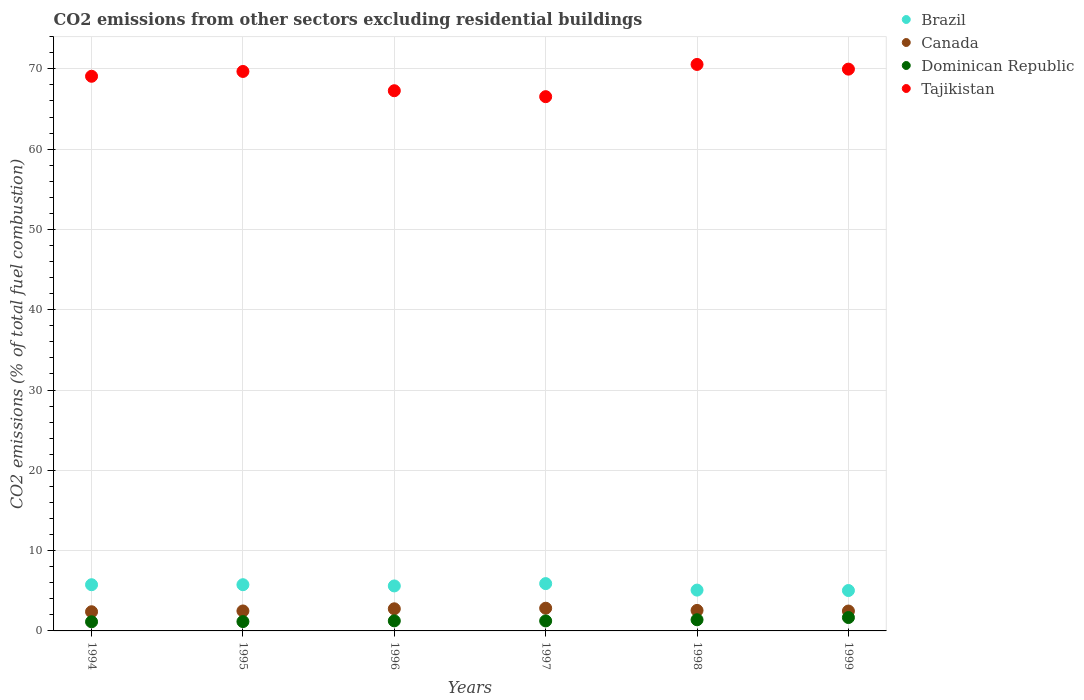How many different coloured dotlines are there?
Provide a succinct answer. 4. What is the total CO2 emitted in Tajikistan in 1994?
Provide a short and direct response. 69.07. Across all years, what is the maximum total CO2 emitted in Dominican Republic?
Provide a succinct answer. 1.67. Across all years, what is the minimum total CO2 emitted in Tajikistan?
Your answer should be very brief. 66.53. In which year was the total CO2 emitted in Dominican Republic maximum?
Keep it short and to the point. 1999. In which year was the total CO2 emitted in Tajikistan minimum?
Your response must be concise. 1997. What is the total total CO2 emitted in Canada in the graph?
Your answer should be compact. 15.49. What is the difference between the total CO2 emitted in Tajikistan in 1997 and that in 1999?
Ensure brevity in your answer.  -3.43. What is the difference between the total CO2 emitted in Brazil in 1997 and the total CO2 emitted in Tajikistan in 1996?
Ensure brevity in your answer.  -61.38. What is the average total CO2 emitted in Canada per year?
Ensure brevity in your answer.  2.58. In the year 1999, what is the difference between the total CO2 emitted in Dominican Republic and total CO2 emitted in Canada?
Give a very brief answer. -0.81. In how many years, is the total CO2 emitted in Canada greater than 58?
Ensure brevity in your answer.  0. What is the ratio of the total CO2 emitted in Canada in 1997 to that in 1998?
Your answer should be compact. 1.11. Is the difference between the total CO2 emitted in Dominican Republic in 1994 and 1999 greater than the difference between the total CO2 emitted in Canada in 1994 and 1999?
Give a very brief answer. No. What is the difference between the highest and the second highest total CO2 emitted in Canada?
Your response must be concise. 0.07. What is the difference between the highest and the lowest total CO2 emitted in Brazil?
Your answer should be very brief. 0.86. Is it the case that in every year, the sum of the total CO2 emitted in Tajikistan and total CO2 emitted in Canada  is greater than the sum of total CO2 emitted in Dominican Republic and total CO2 emitted in Brazil?
Make the answer very short. Yes. Is it the case that in every year, the sum of the total CO2 emitted in Dominican Republic and total CO2 emitted in Canada  is greater than the total CO2 emitted in Tajikistan?
Your response must be concise. No. Does the total CO2 emitted in Dominican Republic monotonically increase over the years?
Ensure brevity in your answer.  No. Is the total CO2 emitted in Brazil strictly greater than the total CO2 emitted in Tajikistan over the years?
Make the answer very short. No. Is the total CO2 emitted in Brazil strictly less than the total CO2 emitted in Tajikistan over the years?
Offer a very short reply. Yes. How many dotlines are there?
Provide a succinct answer. 4. How many years are there in the graph?
Provide a succinct answer. 6. What is the difference between two consecutive major ticks on the Y-axis?
Keep it short and to the point. 10. Are the values on the major ticks of Y-axis written in scientific E-notation?
Ensure brevity in your answer.  No. Does the graph contain any zero values?
Offer a very short reply. No. Does the graph contain grids?
Offer a very short reply. Yes. How are the legend labels stacked?
Provide a short and direct response. Vertical. What is the title of the graph?
Offer a terse response. CO2 emissions from other sectors excluding residential buildings. What is the label or title of the X-axis?
Your answer should be very brief. Years. What is the label or title of the Y-axis?
Provide a short and direct response. CO2 emissions (% of total fuel combustion). What is the CO2 emissions (% of total fuel combustion) of Brazil in 1994?
Keep it short and to the point. 5.75. What is the CO2 emissions (% of total fuel combustion) of Canada in 1994?
Provide a short and direct response. 2.39. What is the CO2 emissions (% of total fuel combustion) of Dominican Republic in 1994?
Make the answer very short. 1.14. What is the CO2 emissions (% of total fuel combustion) in Tajikistan in 1994?
Offer a terse response. 69.07. What is the CO2 emissions (% of total fuel combustion) in Brazil in 1995?
Provide a short and direct response. 5.76. What is the CO2 emissions (% of total fuel combustion) of Canada in 1995?
Ensure brevity in your answer.  2.49. What is the CO2 emissions (% of total fuel combustion) of Dominican Republic in 1995?
Make the answer very short. 1.16. What is the CO2 emissions (% of total fuel combustion) of Tajikistan in 1995?
Give a very brief answer. 69.67. What is the CO2 emissions (% of total fuel combustion) of Brazil in 1996?
Keep it short and to the point. 5.6. What is the CO2 emissions (% of total fuel combustion) in Canada in 1996?
Ensure brevity in your answer.  2.76. What is the CO2 emissions (% of total fuel combustion) in Dominican Republic in 1996?
Keep it short and to the point. 1.25. What is the CO2 emissions (% of total fuel combustion) of Tajikistan in 1996?
Provide a short and direct response. 67.27. What is the CO2 emissions (% of total fuel combustion) of Brazil in 1997?
Give a very brief answer. 5.89. What is the CO2 emissions (% of total fuel combustion) of Canada in 1997?
Your answer should be very brief. 2.83. What is the CO2 emissions (% of total fuel combustion) in Dominican Republic in 1997?
Offer a very short reply. 1.25. What is the CO2 emissions (% of total fuel combustion) in Tajikistan in 1997?
Your answer should be very brief. 66.53. What is the CO2 emissions (% of total fuel combustion) in Brazil in 1998?
Keep it short and to the point. 5.08. What is the CO2 emissions (% of total fuel combustion) in Canada in 1998?
Give a very brief answer. 2.55. What is the CO2 emissions (% of total fuel combustion) in Dominican Republic in 1998?
Offer a terse response. 1.39. What is the CO2 emissions (% of total fuel combustion) in Tajikistan in 1998?
Your answer should be compact. 70.55. What is the CO2 emissions (% of total fuel combustion) in Brazil in 1999?
Ensure brevity in your answer.  5.03. What is the CO2 emissions (% of total fuel combustion) in Canada in 1999?
Your answer should be very brief. 2.48. What is the CO2 emissions (% of total fuel combustion) in Dominican Republic in 1999?
Keep it short and to the point. 1.67. What is the CO2 emissions (% of total fuel combustion) in Tajikistan in 1999?
Your answer should be compact. 69.96. Across all years, what is the maximum CO2 emissions (% of total fuel combustion) in Brazil?
Your answer should be compact. 5.89. Across all years, what is the maximum CO2 emissions (% of total fuel combustion) in Canada?
Ensure brevity in your answer.  2.83. Across all years, what is the maximum CO2 emissions (% of total fuel combustion) in Dominican Republic?
Your answer should be compact. 1.67. Across all years, what is the maximum CO2 emissions (% of total fuel combustion) in Tajikistan?
Keep it short and to the point. 70.55. Across all years, what is the minimum CO2 emissions (% of total fuel combustion) of Brazil?
Offer a terse response. 5.03. Across all years, what is the minimum CO2 emissions (% of total fuel combustion) in Canada?
Offer a very short reply. 2.39. Across all years, what is the minimum CO2 emissions (% of total fuel combustion) in Dominican Republic?
Your answer should be compact. 1.14. Across all years, what is the minimum CO2 emissions (% of total fuel combustion) of Tajikistan?
Ensure brevity in your answer.  66.53. What is the total CO2 emissions (% of total fuel combustion) in Brazil in the graph?
Your answer should be very brief. 33.12. What is the total CO2 emissions (% of total fuel combustion) of Canada in the graph?
Provide a short and direct response. 15.49. What is the total CO2 emissions (% of total fuel combustion) of Dominican Republic in the graph?
Your response must be concise. 7.86. What is the total CO2 emissions (% of total fuel combustion) in Tajikistan in the graph?
Keep it short and to the point. 413.06. What is the difference between the CO2 emissions (% of total fuel combustion) of Brazil in 1994 and that in 1995?
Provide a succinct answer. -0. What is the difference between the CO2 emissions (% of total fuel combustion) in Canada in 1994 and that in 1995?
Make the answer very short. -0.1. What is the difference between the CO2 emissions (% of total fuel combustion) in Dominican Republic in 1994 and that in 1995?
Give a very brief answer. -0.02. What is the difference between the CO2 emissions (% of total fuel combustion) of Brazil in 1994 and that in 1996?
Your answer should be very brief. 0.15. What is the difference between the CO2 emissions (% of total fuel combustion) in Canada in 1994 and that in 1996?
Your answer should be compact. -0.37. What is the difference between the CO2 emissions (% of total fuel combustion) in Dominican Republic in 1994 and that in 1996?
Provide a short and direct response. -0.11. What is the difference between the CO2 emissions (% of total fuel combustion) of Tajikistan in 1994 and that in 1996?
Your response must be concise. 1.8. What is the difference between the CO2 emissions (% of total fuel combustion) of Brazil in 1994 and that in 1997?
Ensure brevity in your answer.  -0.14. What is the difference between the CO2 emissions (% of total fuel combustion) in Canada in 1994 and that in 1997?
Provide a succinct answer. -0.44. What is the difference between the CO2 emissions (% of total fuel combustion) of Dominican Republic in 1994 and that in 1997?
Make the answer very short. -0.11. What is the difference between the CO2 emissions (% of total fuel combustion) of Tajikistan in 1994 and that in 1997?
Your answer should be very brief. 2.54. What is the difference between the CO2 emissions (% of total fuel combustion) of Brazil in 1994 and that in 1998?
Provide a succinct answer. 0.67. What is the difference between the CO2 emissions (% of total fuel combustion) of Canada in 1994 and that in 1998?
Give a very brief answer. -0.17. What is the difference between the CO2 emissions (% of total fuel combustion) in Dominican Republic in 1994 and that in 1998?
Provide a succinct answer. -0.25. What is the difference between the CO2 emissions (% of total fuel combustion) of Tajikistan in 1994 and that in 1998?
Ensure brevity in your answer.  -1.47. What is the difference between the CO2 emissions (% of total fuel combustion) in Brazil in 1994 and that in 1999?
Your answer should be very brief. 0.72. What is the difference between the CO2 emissions (% of total fuel combustion) of Canada in 1994 and that in 1999?
Your response must be concise. -0.09. What is the difference between the CO2 emissions (% of total fuel combustion) of Dominican Republic in 1994 and that in 1999?
Ensure brevity in your answer.  -0.53. What is the difference between the CO2 emissions (% of total fuel combustion) in Tajikistan in 1994 and that in 1999?
Offer a very short reply. -0.89. What is the difference between the CO2 emissions (% of total fuel combustion) in Brazil in 1995 and that in 1996?
Give a very brief answer. 0.15. What is the difference between the CO2 emissions (% of total fuel combustion) of Canada in 1995 and that in 1996?
Your answer should be compact. -0.27. What is the difference between the CO2 emissions (% of total fuel combustion) in Dominican Republic in 1995 and that in 1996?
Ensure brevity in your answer.  -0.09. What is the difference between the CO2 emissions (% of total fuel combustion) of Tajikistan in 1995 and that in 1996?
Give a very brief answer. 2.4. What is the difference between the CO2 emissions (% of total fuel combustion) of Brazil in 1995 and that in 1997?
Keep it short and to the point. -0.14. What is the difference between the CO2 emissions (% of total fuel combustion) in Canada in 1995 and that in 1997?
Your answer should be compact. -0.34. What is the difference between the CO2 emissions (% of total fuel combustion) in Dominican Republic in 1995 and that in 1997?
Provide a short and direct response. -0.08. What is the difference between the CO2 emissions (% of total fuel combustion) in Tajikistan in 1995 and that in 1997?
Your response must be concise. 3.14. What is the difference between the CO2 emissions (% of total fuel combustion) of Brazil in 1995 and that in 1998?
Ensure brevity in your answer.  0.67. What is the difference between the CO2 emissions (% of total fuel combustion) of Canada in 1995 and that in 1998?
Offer a very short reply. -0.07. What is the difference between the CO2 emissions (% of total fuel combustion) in Dominican Republic in 1995 and that in 1998?
Your answer should be compact. -0.23. What is the difference between the CO2 emissions (% of total fuel combustion) in Tajikistan in 1995 and that in 1998?
Provide a succinct answer. -0.87. What is the difference between the CO2 emissions (% of total fuel combustion) in Brazil in 1995 and that in 1999?
Your response must be concise. 0.73. What is the difference between the CO2 emissions (% of total fuel combustion) in Canada in 1995 and that in 1999?
Provide a succinct answer. 0.01. What is the difference between the CO2 emissions (% of total fuel combustion) of Dominican Republic in 1995 and that in 1999?
Give a very brief answer. -0.5. What is the difference between the CO2 emissions (% of total fuel combustion) in Tajikistan in 1995 and that in 1999?
Keep it short and to the point. -0.29. What is the difference between the CO2 emissions (% of total fuel combustion) in Brazil in 1996 and that in 1997?
Ensure brevity in your answer.  -0.29. What is the difference between the CO2 emissions (% of total fuel combustion) in Canada in 1996 and that in 1997?
Provide a succinct answer. -0.07. What is the difference between the CO2 emissions (% of total fuel combustion) in Dominican Republic in 1996 and that in 1997?
Your response must be concise. 0.01. What is the difference between the CO2 emissions (% of total fuel combustion) of Tajikistan in 1996 and that in 1997?
Your answer should be compact. 0.74. What is the difference between the CO2 emissions (% of total fuel combustion) of Brazil in 1996 and that in 1998?
Offer a terse response. 0.52. What is the difference between the CO2 emissions (% of total fuel combustion) in Canada in 1996 and that in 1998?
Offer a terse response. 0.2. What is the difference between the CO2 emissions (% of total fuel combustion) in Dominican Republic in 1996 and that in 1998?
Keep it short and to the point. -0.14. What is the difference between the CO2 emissions (% of total fuel combustion) of Tajikistan in 1996 and that in 1998?
Your response must be concise. -3.27. What is the difference between the CO2 emissions (% of total fuel combustion) in Brazil in 1996 and that in 1999?
Your answer should be compact. 0.57. What is the difference between the CO2 emissions (% of total fuel combustion) in Canada in 1996 and that in 1999?
Ensure brevity in your answer.  0.28. What is the difference between the CO2 emissions (% of total fuel combustion) of Dominican Republic in 1996 and that in 1999?
Keep it short and to the point. -0.41. What is the difference between the CO2 emissions (% of total fuel combustion) in Tajikistan in 1996 and that in 1999?
Offer a terse response. -2.69. What is the difference between the CO2 emissions (% of total fuel combustion) of Brazil in 1997 and that in 1998?
Offer a very short reply. 0.81. What is the difference between the CO2 emissions (% of total fuel combustion) of Canada in 1997 and that in 1998?
Offer a very short reply. 0.27. What is the difference between the CO2 emissions (% of total fuel combustion) in Dominican Republic in 1997 and that in 1998?
Make the answer very short. -0.15. What is the difference between the CO2 emissions (% of total fuel combustion) in Tajikistan in 1997 and that in 1998?
Your response must be concise. -4.01. What is the difference between the CO2 emissions (% of total fuel combustion) in Brazil in 1997 and that in 1999?
Offer a terse response. 0.86. What is the difference between the CO2 emissions (% of total fuel combustion) of Canada in 1997 and that in 1999?
Your answer should be compact. 0.35. What is the difference between the CO2 emissions (% of total fuel combustion) of Dominican Republic in 1997 and that in 1999?
Offer a very short reply. -0.42. What is the difference between the CO2 emissions (% of total fuel combustion) of Tajikistan in 1997 and that in 1999?
Make the answer very short. -3.43. What is the difference between the CO2 emissions (% of total fuel combustion) of Brazil in 1998 and that in 1999?
Your answer should be compact. 0.05. What is the difference between the CO2 emissions (% of total fuel combustion) in Canada in 1998 and that in 1999?
Ensure brevity in your answer.  0.08. What is the difference between the CO2 emissions (% of total fuel combustion) in Dominican Republic in 1998 and that in 1999?
Ensure brevity in your answer.  -0.28. What is the difference between the CO2 emissions (% of total fuel combustion) in Tajikistan in 1998 and that in 1999?
Your response must be concise. 0.58. What is the difference between the CO2 emissions (% of total fuel combustion) of Brazil in 1994 and the CO2 emissions (% of total fuel combustion) of Canada in 1995?
Provide a succinct answer. 3.27. What is the difference between the CO2 emissions (% of total fuel combustion) in Brazil in 1994 and the CO2 emissions (% of total fuel combustion) in Dominican Republic in 1995?
Your answer should be very brief. 4.59. What is the difference between the CO2 emissions (% of total fuel combustion) of Brazil in 1994 and the CO2 emissions (% of total fuel combustion) of Tajikistan in 1995?
Offer a terse response. -63.92. What is the difference between the CO2 emissions (% of total fuel combustion) of Canada in 1994 and the CO2 emissions (% of total fuel combustion) of Dominican Republic in 1995?
Offer a terse response. 1.23. What is the difference between the CO2 emissions (% of total fuel combustion) of Canada in 1994 and the CO2 emissions (% of total fuel combustion) of Tajikistan in 1995?
Offer a very short reply. -67.28. What is the difference between the CO2 emissions (% of total fuel combustion) in Dominican Republic in 1994 and the CO2 emissions (% of total fuel combustion) in Tajikistan in 1995?
Offer a very short reply. -68.53. What is the difference between the CO2 emissions (% of total fuel combustion) of Brazil in 1994 and the CO2 emissions (% of total fuel combustion) of Canada in 1996?
Offer a very short reply. 3. What is the difference between the CO2 emissions (% of total fuel combustion) in Brazil in 1994 and the CO2 emissions (% of total fuel combustion) in Dominican Republic in 1996?
Provide a short and direct response. 4.5. What is the difference between the CO2 emissions (% of total fuel combustion) of Brazil in 1994 and the CO2 emissions (% of total fuel combustion) of Tajikistan in 1996?
Keep it short and to the point. -61.52. What is the difference between the CO2 emissions (% of total fuel combustion) of Canada in 1994 and the CO2 emissions (% of total fuel combustion) of Dominican Republic in 1996?
Keep it short and to the point. 1.13. What is the difference between the CO2 emissions (% of total fuel combustion) of Canada in 1994 and the CO2 emissions (% of total fuel combustion) of Tajikistan in 1996?
Provide a short and direct response. -64.88. What is the difference between the CO2 emissions (% of total fuel combustion) of Dominican Republic in 1994 and the CO2 emissions (% of total fuel combustion) of Tajikistan in 1996?
Offer a terse response. -66.13. What is the difference between the CO2 emissions (% of total fuel combustion) of Brazil in 1994 and the CO2 emissions (% of total fuel combustion) of Canada in 1997?
Ensure brevity in your answer.  2.93. What is the difference between the CO2 emissions (% of total fuel combustion) in Brazil in 1994 and the CO2 emissions (% of total fuel combustion) in Dominican Republic in 1997?
Offer a very short reply. 4.51. What is the difference between the CO2 emissions (% of total fuel combustion) in Brazil in 1994 and the CO2 emissions (% of total fuel combustion) in Tajikistan in 1997?
Your answer should be compact. -60.78. What is the difference between the CO2 emissions (% of total fuel combustion) of Canada in 1994 and the CO2 emissions (% of total fuel combustion) of Dominican Republic in 1997?
Offer a terse response. 1.14. What is the difference between the CO2 emissions (% of total fuel combustion) of Canada in 1994 and the CO2 emissions (% of total fuel combustion) of Tajikistan in 1997?
Offer a very short reply. -64.14. What is the difference between the CO2 emissions (% of total fuel combustion) of Dominican Republic in 1994 and the CO2 emissions (% of total fuel combustion) of Tajikistan in 1997?
Your response must be concise. -65.39. What is the difference between the CO2 emissions (% of total fuel combustion) of Brazil in 1994 and the CO2 emissions (% of total fuel combustion) of Canada in 1998?
Give a very brief answer. 3.2. What is the difference between the CO2 emissions (% of total fuel combustion) of Brazil in 1994 and the CO2 emissions (% of total fuel combustion) of Dominican Republic in 1998?
Your answer should be compact. 4.36. What is the difference between the CO2 emissions (% of total fuel combustion) in Brazil in 1994 and the CO2 emissions (% of total fuel combustion) in Tajikistan in 1998?
Offer a very short reply. -64.79. What is the difference between the CO2 emissions (% of total fuel combustion) of Canada in 1994 and the CO2 emissions (% of total fuel combustion) of Tajikistan in 1998?
Provide a short and direct response. -68.16. What is the difference between the CO2 emissions (% of total fuel combustion) of Dominican Republic in 1994 and the CO2 emissions (% of total fuel combustion) of Tajikistan in 1998?
Provide a short and direct response. -69.41. What is the difference between the CO2 emissions (% of total fuel combustion) of Brazil in 1994 and the CO2 emissions (% of total fuel combustion) of Canada in 1999?
Give a very brief answer. 3.28. What is the difference between the CO2 emissions (% of total fuel combustion) of Brazil in 1994 and the CO2 emissions (% of total fuel combustion) of Dominican Republic in 1999?
Your answer should be very brief. 4.09. What is the difference between the CO2 emissions (% of total fuel combustion) in Brazil in 1994 and the CO2 emissions (% of total fuel combustion) in Tajikistan in 1999?
Make the answer very short. -64.21. What is the difference between the CO2 emissions (% of total fuel combustion) of Canada in 1994 and the CO2 emissions (% of total fuel combustion) of Dominican Republic in 1999?
Ensure brevity in your answer.  0.72. What is the difference between the CO2 emissions (% of total fuel combustion) of Canada in 1994 and the CO2 emissions (% of total fuel combustion) of Tajikistan in 1999?
Make the answer very short. -67.57. What is the difference between the CO2 emissions (% of total fuel combustion) of Dominican Republic in 1994 and the CO2 emissions (% of total fuel combustion) of Tajikistan in 1999?
Provide a short and direct response. -68.82. What is the difference between the CO2 emissions (% of total fuel combustion) in Brazil in 1995 and the CO2 emissions (% of total fuel combustion) in Canada in 1996?
Keep it short and to the point. 3. What is the difference between the CO2 emissions (% of total fuel combustion) in Brazil in 1995 and the CO2 emissions (% of total fuel combustion) in Dominican Republic in 1996?
Provide a short and direct response. 4.5. What is the difference between the CO2 emissions (% of total fuel combustion) in Brazil in 1995 and the CO2 emissions (% of total fuel combustion) in Tajikistan in 1996?
Your answer should be very brief. -61.52. What is the difference between the CO2 emissions (% of total fuel combustion) of Canada in 1995 and the CO2 emissions (% of total fuel combustion) of Dominican Republic in 1996?
Make the answer very short. 1.23. What is the difference between the CO2 emissions (% of total fuel combustion) of Canada in 1995 and the CO2 emissions (% of total fuel combustion) of Tajikistan in 1996?
Your answer should be very brief. -64.79. What is the difference between the CO2 emissions (% of total fuel combustion) of Dominican Republic in 1995 and the CO2 emissions (% of total fuel combustion) of Tajikistan in 1996?
Keep it short and to the point. -66.11. What is the difference between the CO2 emissions (% of total fuel combustion) in Brazil in 1995 and the CO2 emissions (% of total fuel combustion) in Canada in 1997?
Your answer should be compact. 2.93. What is the difference between the CO2 emissions (% of total fuel combustion) of Brazil in 1995 and the CO2 emissions (% of total fuel combustion) of Dominican Republic in 1997?
Provide a short and direct response. 4.51. What is the difference between the CO2 emissions (% of total fuel combustion) of Brazil in 1995 and the CO2 emissions (% of total fuel combustion) of Tajikistan in 1997?
Keep it short and to the point. -60.78. What is the difference between the CO2 emissions (% of total fuel combustion) in Canada in 1995 and the CO2 emissions (% of total fuel combustion) in Dominican Republic in 1997?
Make the answer very short. 1.24. What is the difference between the CO2 emissions (% of total fuel combustion) of Canada in 1995 and the CO2 emissions (% of total fuel combustion) of Tajikistan in 1997?
Your answer should be compact. -64.05. What is the difference between the CO2 emissions (% of total fuel combustion) of Dominican Republic in 1995 and the CO2 emissions (% of total fuel combustion) of Tajikistan in 1997?
Your response must be concise. -65.37. What is the difference between the CO2 emissions (% of total fuel combustion) of Brazil in 1995 and the CO2 emissions (% of total fuel combustion) of Canada in 1998?
Keep it short and to the point. 3.2. What is the difference between the CO2 emissions (% of total fuel combustion) in Brazil in 1995 and the CO2 emissions (% of total fuel combustion) in Dominican Republic in 1998?
Make the answer very short. 4.37. What is the difference between the CO2 emissions (% of total fuel combustion) in Brazil in 1995 and the CO2 emissions (% of total fuel combustion) in Tajikistan in 1998?
Offer a very short reply. -64.79. What is the difference between the CO2 emissions (% of total fuel combustion) in Canada in 1995 and the CO2 emissions (% of total fuel combustion) in Dominican Republic in 1998?
Offer a very short reply. 1.1. What is the difference between the CO2 emissions (% of total fuel combustion) in Canada in 1995 and the CO2 emissions (% of total fuel combustion) in Tajikistan in 1998?
Make the answer very short. -68.06. What is the difference between the CO2 emissions (% of total fuel combustion) in Dominican Republic in 1995 and the CO2 emissions (% of total fuel combustion) in Tajikistan in 1998?
Your answer should be very brief. -69.38. What is the difference between the CO2 emissions (% of total fuel combustion) of Brazil in 1995 and the CO2 emissions (% of total fuel combustion) of Canada in 1999?
Ensure brevity in your answer.  3.28. What is the difference between the CO2 emissions (% of total fuel combustion) of Brazil in 1995 and the CO2 emissions (% of total fuel combustion) of Dominican Republic in 1999?
Make the answer very short. 4.09. What is the difference between the CO2 emissions (% of total fuel combustion) in Brazil in 1995 and the CO2 emissions (% of total fuel combustion) in Tajikistan in 1999?
Your response must be concise. -64.2. What is the difference between the CO2 emissions (% of total fuel combustion) of Canada in 1995 and the CO2 emissions (% of total fuel combustion) of Dominican Republic in 1999?
Your answer should be compact. 0.82. What is the difference between the CO2 emissions (% of total fuel combustion) in Canada in 1995 and the CO2 emissions (% of total fuel combustion) in Tajikistan in 1999?
Your answer should be very brief. -67.47. What is the difference between the CO2 emissions (% of total fuel combustion) of Dominican Republic in 1995 and the CO2 emissions (% of total fuel combustion) of Tajikistan in 1999?
Ensure brevity in your answer.  -68.8. What is the difference between the CO2 emissions (% of total fuel combustion) of Brazil in 1996 and the CO2 emissions (% of total fuel combustion) of Canada in 1997?
Give a very brief answer. 2.78. What is the difference between the CO2 emissions (% of total fuel combustion) of Brazil in 1996 and the CO2 emissions (% of total fuel combustion) of Dominican Republic in 1997?
Your response must be concise. 4.36. What is the difference between the CO2 emissions (% of total fuel combustion) in Brazil in 1996 and the CO2 emissions (% of total fuel combustion) in Tajikistan in 1997?
Ensure brevity in your answer.  -60.93. What is the difference between the CO2 emissions (% of total fuel combustion) in Canada in 1996 and the CO2 emissions (% of total fuel combustion) in Dominican Republic in 1997?
Offer a terse response. 1.51. What is the difference between the CO2 emissions (% of total fuel combustion) of Canada in 1996 and the CO2 emissions (% of total fuel combustion) of Tajikistan in 1997?
Provide a succinct answer. -63.78. What is the difference between the CO2 emissions (% of total fuel combustion) in Dominican Republic in 1996 and the CO2 emissions (% of total fuel combustion) in Tajikistan in 1997?
Your response must be concise. -65.28. What is the difference between the CO2 emissions (% of total fuel combustion) in Brazil in 1996 and the CO2 emissions (% of total fuel combustion) in Canada in 1998?
Your answer should be very brief. 3.05. What is the difference between the CO2 emissions (% of total fuel combustion) in Brazil in 1996 and the CO2 emissions (% of total fuel combustion) in Dominican Republic in 1998?
Provide a succinct answer. 4.21. What is the difference between the CO2 emissions (% of total fuel combustion) of Brazil in 1996 and the CO2 emissions (% of total fuel combustion) of Tajikistan in 1998?
Make the answer very short. -64.94. What is the difference between the CO2 emissions (% of total fuel combustion) in Canada in 1996 and the CO2 emissions (% of total fuel combustion) in Dominican Republic in 1998?
Your answer should be very brief. 1.36. What is the difference between the CO2 emissions (% of total fuel combustion) of Canada in 1996 and the CO2 emissions (% of total fuel combustion) of Tajikistan in 1998?
Keep it short and to the point. -67.79. What is the difference between the CO2 emissions (% of total fuel combustion) of Dominican Republic in 1996 and the CO2 emissions (% of total fuel combustion) of Tajikistan in 1998?
Provide a short and direct response. -69.29. What is the difference between the CO2 emissions (% of total fuel combustion) of Brazil in 1996 and the CO2 emissions (% of total fuel combustion) of Canada in 1999?
Ensure brevity in your answer.  3.13. What is the difference between the CO2 emissions (% of total fuel combustion) of Brazil in 1996 and the CO2 emissions (% of total fuel combustion) of Dominican Republic in 1999?
Ensure brevity in your answer.  3.94. What is the difference between the CO2 emissions (% of total fuel combustion) of Brazil in 1996 and the CO2 emissions (% of total fuel combustion) of Tajikistan in 1999?
Provide a short and direct response. -64.36. What is the difference between the CO2 emissions (% of total fuel combustion) in Canada in 1996 and the CO2 emissions (% of total fuel combustion) in Dominican Republic in 1999?
Your answer should be compact. 1.09. What is the difference between the CO2 emissions (% of total fuel combustion) in Canada in 1996 and the CO2 emissions (% of total fuel combustion) in Tajikistan in 1999?
Your answer should be compact. -67.21. What is the difference between the CO2 emissions (% of total fuel combustion) in Dominican Republic in 1996 and the CO2 emissions (% of total fuel combustion) in Tajikistan in 1999?
Offer a terse response. -68.71. What is the difference between the CO2 emissions (% of total fuel combustion) of Brazil in 1997 and the CO2 emissions (% of total fuel combustion) of Canada in 1998?
Your answer should be compact. 3.34. What is the difference between the CO2 emissions (% of total fuel combustion) of Brazil in 1997 and the CO2 emissions (% of total fuel combustion) of Dominican Republic in 1998?
Your response must be concise. 4.5. What is the difference between the CO2 emissions (% of total fuel combustion) in Brazil in 1997 and the CO2 emissions (% of total fuel combustion) in Tajikistan in 1998?
Your response must be concise. -64.65. What is the difference between the CO2 emissions (% of total fuel combustion) of Canada in 1997 and the CO2 emissions (% of total fuel combustion) of Dominican Republic in 1998?
Provide a short and direct response. 1.44. What is the difference between the CO2 emissions (% of total fuel combustion) in Canada in 1997 and the CO2 emissions (% of total fuel combustion) in Tajikistan in 1998?
Give a very brief answer. -67.72. What is the difference between the CO2 emissions (% of total fuel combustion) in Dominican Republic in 1997 and the CO2 emissions (% of total fuel combustion) in Tajikistan in 1998?
Provide a short and direct response. -69.3. What is the difference between the CO2 emissions (% of total fuel combustion) of Brazil in 1997 and the CO2 emissions (% of total fuel combustion) of Canada in 1999?
Your answer should be compact. 3.42. What is the difference between the CO2 emissions (% of total fuel combustion) of Brazil in 1997 and the CO2 emissions (% of total fuel combustion) of Dominican Republic in 1999?
Offer a very short reply. 4.23. What is the difference between the CO2 emissions (% of total fuel combustion) in Brazil in 1997 and the CO2 emissions (% of total fuel combustion) in Tajikistan in 1999?
Your response must be concise. -64.07. What is the difference between the CO2 emissions (% of total fuel combustion) of Canada in 1997 and the CO2 emissions (% of total fuel combustion) of Dominican Republic in 1999?
Give a very brief answer. 1.16. What is the difference between the CO2 emissions (% of total fuel combustion) of Canada in 1997 and the CO2 emissions (% of total fuel combustion) of Tajikistan in 1999?
Give a very brief answer. -67.13. What is the difference between the CO2 emissions (% of total fuel combustion) in Dominican Republic in 1997 and the CO2 emissions (% of total fuel combustion) in Tajikistan in 1999?
Your answer should be compact. -68.72. What is the difference between the CO2 emissions (% of total fuel combustion) of Brazil in 1998 and the CO2 emissions (% of total fuel combustion) of Canada in 1999?
Ensure brevity in your answer.  2.61. What is the difference between the CO2 emissions (% of total fuel combustion) in Brazil in 1998 and the CO2 emissions (% of total fuel combustion) in Dominican Republic in 1999?
Provide a short and direct response. 3.42. What is the difference between the CO2 emissions (% of total fuel combustion) in Brazil in 1998 and the CO2 emissions (% of total fuel combustion) in Tajikistan in 1999?
Your response must be concise. -64.88. What is the difference between the CO2 emissions (% of total fuel combustion) in Canada in 1998 and the CO2 emissions (% of total fuel combustion) in Dominican Republic in 1999?
Make the answer very short. 0.89. What is the difference between the CO2 emissions (% of total fuel combustion) in Canada in 1998 and the CO2 emissions (% of total fuel combustion) in Tajikistan in 1999?
Make the answer very short. -67.41. What is the difference between the CO2 emissions (% of total fuel combustion) of Dominican Republic in 1998 and the CO2 emissions (% of total fuel combustion) of Tajikistan in 1999?
Offer a terse response. -68.57. What is the average CO2 emissions (% of total fuel combustion) in Brazil per year?
Make the answer very short. 5.52. What is the average CO2 emissions (% of total fuel combustion) in Canada per year?
Keep it short and to the point. 2.58. What is the average CO2 emissions (% of total fuel combustion) of Dominican Republic per year?
Give a very brief answer. 1.31. What is the average CO2 emissions (% of total fuel combustion) of Tajikistan per year?
Give a very brief answer. 68.84. In the year 1994, what is the difference between the CO2 emissions (% of total fuel combustion) in Brazil and CO2 emissions (% of total fuel combustion) in Canada?
Ensure brevity in your answer.  3.36. In the year 1994, what is the difference between the CO2 emissions (% of total fuel combustion) of Brazil and CO2 emissions (% of total fuel combustion) of Dominican Republic?
Offer a very short reply. 4.61. In the year 1994, what is the difference between the CO2 emissions (% of total fuel combustion) in Brazil and CO2 emissions (% of total fuel combustion) in Tajikistan?
Offer a very short reply. -63.32. In the year 1994, what is the difference between the CO2 emissions (% of total fuel combustion) of Canada and CO2 emissions (% of total fuel combustion) of Dominican Republic?
Your answer should be compact. 1.25. In the year 1994, what is the difference between the CO2 emissions (% of total fuel combustion) in Canada and CO2 emissions (% of total fuel combustion) in Tajikistan?
Give a very brief answer. -66.68. In the year 1994, what is the difference between the CO2 emissions (% of total fuel combustion) in Dominican Republic and CO2 emissions (% of total fuel combustion) in Tajikistan?
Your answer should be compact. -67.93. In the year 1995, what is the difference between the CO2 emissions (% of total fuel combustion) of Brazil and CO2 emissions (% of total fuel combustion) of Canada?
Your answer should be very brief. 3.27. In the year 1995, what is the difference between the CO2 emissions (% of total fuel combustion) in Brazil and CO2 emissions (% of total fuel combustion) in Dominican Republic?
Your answer should be very brief. 4.59. In the year 1995, what is the difference between the CO2 emissions (% of total fuel combustion) of Brazil and CO2 emissions (% of total fuel combustion) of Tajikistan?
Ensure brevity in your answer.  -63.92. In the year 1995, what is the difference between the CO2 emissions (% of total fuel combustion) of Canada and CO2 emissions (% of total fuel combustion) of Dominican Republic?
Your answer should be compact. 1.32. In the year 1995, what is the difference between the CO2 emissions (% of total fuel combustion) of Canada and CO2 emissions (% of total fuel combustion) of Tajikistan?
Keep it short and to the point. -67.19. In the year 1995, what is the difference between the CO2 emissions (% of total fuel combustion) of Dominican Republic and CO2 emissions (% of total fuel combustion) of Tajikistan?
Your answer should be compact. -68.51. In the year 1996, what is the difference between the CO2 emissions (% of total fuel combustion) of Brazil and CO2 emissions (% of total fuel combustion) of Canada?
Keep it short and to the point. 2.85. In the year 1996, what is the difference between the CO2 emissions (% of total fuel combustion) in Brazil and CO2 emissions (% of total fuel combustion) in Dominican Republic?
Provide a short and direct response. 4.35. In the year 1996, what is the difference between the CO2 emissions (% of total fuel combustion) in Brazil and CO2 emissions (% of total fuel combustion) in Tajikistan?
Ensure brevity in your answer.  -61.67. In the year 1996, what is the difference between the CO2 emissions (% of total fuel combustion) in Canada and CO2 emissions (% of total fuel combustion) in Dominican Republic?
Offer a terse response. 1.5. In the year 1996, what is the difference between the CO2 emissions (% of total fuel combustion) in Canada and CO2 emissions (% of total fuel combustion) in Tajikistan?
Give a very brief answer. -64.52. In the year 1996, what is the difference between the CO2 emissions (% of total fuel combustion) of Dominican Republic and CO2 emissions (% of total fuel combustion) of Tajikistan?
Your response must be concise. -66.02. In the year 1997, what is the difference between the CO2 emissions (% of total fuel combustion) in Brazil and CO2 emissions (% of total fuel combustion) in Canada?
Your answer should be compact. 3.07. In the year 1997, what is the difference between the CO2 emissions (% of total fuel combustion) in Brazil and CO2 emissions (% of total fuel combustion) in Dominican Republic?
Your response must be concise. 4.65. In the year 1997, what is the difference between the CO2 emissions (% of total fuel combustion) in Brazil and CO2 emissions (% of total fuel combustion) in Tajikistan?
Offer a terse response. -60.64. In the year 1997, what is the difference between the CO2 emissions (% of total fuel combustion) of Canada and CO2 emissions (% of total fuel combustion) of Dominican Republic?
Your answer should be very brief. 1.58. In the year 1997, what is the difference between the CO2 emissions (% of total fuel combustion) of Canada and CO2 emissions (% of total fuel combustion) of Tajikistan?
Keep it short and to the point. -63.71. In the year 1997, what is the difference between the CO2 emissions (% of total fuel combustion) of Dominican Republic and CO2 emissions (% of total fuel combustion) of Tajikistan?
Offer a terse response. -65.29. In the year 1998, what is the difference between the CO2 emissions (% of total fuel combustion) of Brazil and CO2 emissions (% of total fuel combustion) of Canada?
Offer a terse response. 2.53. In the year 1998, what is the difference between the CO2 emissions (% of total fuel combustion) in Brazil and CO2 emissions (% of total fuel combustion) in Dominican Republic?
Give a very brief answer. 3.69. In the year 1998, what is the difference between the CO2 emissions (% of total fuel combustion) of Brazil and CO2 emissions (% of total fuel combustion) of Tajikistan?
Make the answer very short. -65.46. In the year 1998, what is the difference between the CO2 emissions (% of total fuel combustion) in Canada and CO2 emissions (% of total fuel combustion) in Dominican Republic?
Make the answer very short. 1.16. In the year 1998, what is the difference between the CO2 emissions (% of total fuel combustion) of Canada and CO2 emissions (% of total fuel combustion) of Tajikistan?
Offer a terse response. -67.99. In the year 1998, what is the difference between the CO2 emissions (% of total fuel combustion) in Dominican Republic and CO2 emissions (% of total fuel combustion) in Tajikistan?
Provide a succinct answer. -69.15. In the year 1999, what is the difference between the CO2 emissions (% of total fuel combustion) of Brazil and CO2 emissions (% of total fuel combustion) of Canada?
Provide a succinct answer. 2.55. In the year 1999, what is the difference between the CO2 emissions (% of total fuel combustion) in Brazil and CO2 emissions (% of total fuel combustion) in Dominican Republic?
Keep it short and to the point. 3.36. In the year 1999, what is the difference between the CO2 emissions (% of total fuel combustion) of Brazil and CO2 emissions (% of total fuel combustion) of Tajikistan?
Ensure brevity in your answer.  -64.93. In the year 1999, what is the difference between the CO2 emissions (% of total fuel combustion) of Canada and CO2 emissions (% of total fuel combustion) of Dominican Republic?
Offer a very short reply. 0.81. In the year 1999, what is the difference between the CO2 emissions (% of total fuel combustion) of Canada and CO2 emissions (% of total fuel combustion) of Tajikistan?
Offer a very short reply. -67.48. In the year 1999, what is the difference between the CO2 emissions (% of total fuel combustion) in Dominican Republic and CO2 emissions (% of total fuel combustion) in Tajikistan?
Your response must be concise. -68.29. What is the ratio of the CO2 emissions (% of total fuel combustion) in Brazil in 1994 to that in 1995?
Offer a terse response. 1. What is the ratio of the CO2 emissions (% of total fuel combustion) in Canada in 1994 to that in 1995?
Make the answer very short. 0.96. What is the ratio of the CO2 emissions (% of total fuel combustion) in Dominican Republic in 1994 to that in 1995?
Offer a very short reply. 0.98. What is the ratio of the CO2 emissions (% of total fuel combustion) of Brazil in 1994 to that in 1996?
Provide a short and direct response. 1.03. What is the ratio of the CO2 emissions (% of total fuel combustion) of Canada in 1994 to that in 1996?
Offer a very short reply. 0.87. What is the ratio of the CO2 emissions (% of total fuel combustion) in Dominican Republic in 1994 to that in 1996?
Give a very brief answer. 0.91. What is the ratio of the CO2 emissions (% of total fuel combustion) of Tajikistan in 1994 to that in 1996?
Ensure brevity in your answer.  1.03. What is the ratio of the CO2 emissions (% of total fuel combustion) of Brazil in 1994 to that in 1997?
Give a very brief answer. 0.98. What is the ratio of the CO2 emissions (% of total fuel combustion) of Canada in 1994 to that in 1997?
Keep it short and to the point. 0.84. What is the ratio of the CO2 emissions (% of total fuel combustion) in Dominican Republic in 1994 to that in 1997?
Your answer should be very brief. 0.91. What is the ratio of the CO2 emissions (% of total fuel combustion) in Tajikistan in 1994 to that in 1997?
Give a very brief answer. 1.04. What is the ratio of the CO2 emissions (% of total fuel combustion) in Brazil in 1994 to that in 1998?
Your answer should be very brief. 1.13. What is the ratio of the CO2 emissions (% of total fuel combustion) of Canada in 1994 to that in 1998?
Your response must be concise. 0.94. What is the ratio of the CO2 emissions (% of total fuel combustion) in Dominican Republic in 1994 to that in 1998?
Ensure brevity in your answer.  0.82. What is the ratio of the CO2 emissions (% of total fuel combustion) in Tajikistan in 1994 to that in 1998?
Keep it short and to the point. 0.98. What is the ratio of the CO2 emissions (% of total fuel combustion) of Brazil in 1994 to that in 1999?
Offer a terse response. 1.14. What is the ratio of the CO2 emissions (% of total fuel combustion) in Canada in 1994 to that in 1999?
Provide a succinct answer. 0.96. What is the ratio of the CO2 emissions (% of total fuel combustion) in Dominican Republic in 1994 to that in 1999?
Ensure brevity in your answer.  0.68. What is the ratio of the CO2 emissions (% of total fuel combustion) in Tajikistan in 1994 to that in 1999?
Provide a succinct answer. 0.99. What is the ratio of the CO2 emissions (% of total fuel combustion) of Brazil in 1995 to that in 1996?
Provide a short and direct response. 1.03. What is the ratio of the CO2 emissions (% of total fuel combustion) of Canada in 1995 to that in 1996?
Give a very brief answer. 0.9. What is the ratio of the CO2 emissions (% of total fuel combustion) of Dominican Republic in 1995 to that in 1996?
Provide a short and direct response. 0.93. What is the ratio of the CO2 emissions (% of total fuel combustion) of Tajikistan in 1995 to that in 1996?
Your answer should be very brief. 1.04. What is the ratio of the CO2 emissions (% of total fuel combustion) of Brazil in 1995 to that in 1997?
Make the answer very short. 0.98. What is the ratio of the CO2 emissions (% of total fuel combustion) of Canada in 1995 to that in 1997?
Make the answer very short. 0.88. What is the ratio of the CO2 emissions (% of total fuel combustion) of Dominican Republic in 1995 to that in 1997?
Provide a succinct answer. 0.93. What is the ratio of the CO2 emissions (% of total fuel combustion) of Tajikistan in 1995 to that in 1997?
Your answer should be compact. 1.05. What is the ratio of the CO2 emissions (% of total fuel combustion) in Brazil in 1995 to that in 1998?
Provide a succinct answer. 1.13. What is the ratio of the CO2 emissions (% of total fuel combustion) of Canada in 1995 to that in 1998?
Your answer should be very brief. 0.97. What is the ratio of the CO2 emissions (% of total fuel combustion) of Dominican Republic in 1995 to that in 1998?
Offer a very short reply. 0.84. What is the ratio of the CO2 emissions (% of total fuel combustion) in Tajikistan in 1995 to that in 1998?
Provide a succinct answer. 0.99. What is the ratio of the CO2 emissions (% of total fuel combustion) in Brazil in 1995 to that in 1999?
Give a very brief answer. 1.14. What is the ratio of the CO2 emissions (% of total fuel combustion) in Canada in 1995 to that in 1999?
Your answer should be very brief. 1. What is the ratio of the CO2 emissions (% of total fuel combustion) in Dominican Republic in 1995 to that in 1999?
Provide a short and direct response. 0.7. What is the ratio of the CO2 emissions (% of total fuel combustion) of Brazil in 1996 to that in 1997?
Offer a terse response. 0.95. What is the ratio of the CO2 emissions (% of total fuel combustion) of Canada in 1996 to that in 1997?
Offer a very short reply. 0.97. What is the ratio of the CO2 emissions (% of total fuel combustion) of Tajikistan in 1996 to that in 1997?
Offer a terse response. 1.01. What is the ratio of the CO2 emissions (% of total fuel combustion) in Brazil in 1996 to that in 1998?
Give a very brief answer. 1.1. What is the ratio of the CO2 emissions (% of total fuel combustion) in Canada in 1996 to that in 1998?
Make the answer very short. 1.08. What is the ratio of the CO2 emissions (% of total fuel combustion) of Dominican Republic in 1996 to that in 1998?
Make the answer very short. 0.9. What is the ratio of the CO2 emissions (% of total fuel combustion) of Tajikistan in 1996 to that in 1998?
Ensure brevity in your answer.  0.95. What is the ratio of the CO2 emissions (% of total fuel combustion) in Brazil in 1996 to that in 1999?
Make the answer very short. 1.11. What is the ratio of the CO2 emissions (% of total fuel combustion) in Canada in 1996 to that in 1999?
Provide a short and direct response. 1.11. What is the ratio of the CO2 emissions (% of total fuel combustion) in Dominican Republic in 1996 to that in 1999?
Make the answer very short. 0.75. What is the ratio of the CO2 emissions (% of total fuel combustion) of Tajikistan in 1996 to that in 1999?
Provide a short and direct response. 0.96. What is the ratio of the CO2 emissions (% of total fuel combustion) of Brazil in 1997 to that in 1998?
Make the answer very short. 1.16. What is the ratio of the CO2 emissions (% of total fuel combustion) of Canada in 1997 to that in 1998?
Give a very brief answer. 1.11. What is the ratio of the CO2 emissions (% of total fuel combustion) of Dominican Republic in 1997 to that in 1998?
Keep it short and to the point. 0.9. What is the ratio of the CO2 emissions (% of total fuel combustion) in Tajikistan in 1997 to that in 1998?
Your answer should be compact. 0.94. What is the ratio of the CO2 emissions (% of total fuel combustion) of Brazil in 1997 to that in 1999?
Your response must be concise. 1.17. What is the ratio of the CO2 emissions (% of total fuel combustion) of Canada in 1997 to that in 1999?
Offer a very short reply. 1.14. What is the ratio of the CO2 emissions (% of total fuel combustion) of Dominican Republic in 1997 to that in 1999?
Keep it short and to the point. 0.75. What is the ratio of the CO2 emissions (% of total fuel combustion) of Tajikistan in 1997 to that in 1999?
Provide a short and direct response. 0.95. What is the ratio of the CO2 emissions (% of total fuel combustion) in Brazil in 1998 to that in 1999?
Offer a terse response. 1.01. What is the ratio of the CO2 emissions (% of total fuel combustion) of Canada in 1998 to that in 1999?
Make the answer very short. 1.03. What is the ratio of the CO2 emissions (% of total fuel combustion) of Dominican Republic in 1998 to that in 1999?
Your response must be concise. 0.83. What is the ratio of the CO2 emissions (% of total fuel combustion) in Tajikistan in 1998 to that in 1999?
Provide a short and direct response. 1.01. What is the difference between the highest and the second highest CO2 emissions (% of total fuel combustion) of Brazil?
Offer a terse response. 0.14. What is the difference between the highest and the second highest CO2 emissions (% of total fuel combustion) of Canada?
Your response must be concise. 0.07. What is the difference between the highest and the second highest CO2 emissions (% of total fuel combustion) in Dominican Republic?
Your answer should be very brief. 0.28. What is the difference between the highest and the second highest CO2 emissions (% of total fuel combustion) in Tajikistan?
Give a very brief answer. 0.58. What is the difference between the highest and the lowest CO2 emissions (% of total fuel combustion) in Brazil?
Ensure brevity in your answer.  0.86. What is the difference between the highest and the lowest CO2 emissions (% of total fuel combustion) in Canada?
Your answer should be compact. 0.44. What is the difference between the highest and the lowest CO2 emissions (% of total fuel combustion) in Dominican Republic?
Your answer should be compact. 0.53. What is the difference between the highest and the lowest CO2 emissions (% of total fuel combustion) in Tajikistan?
Your answer should be very brief. 4.01. 